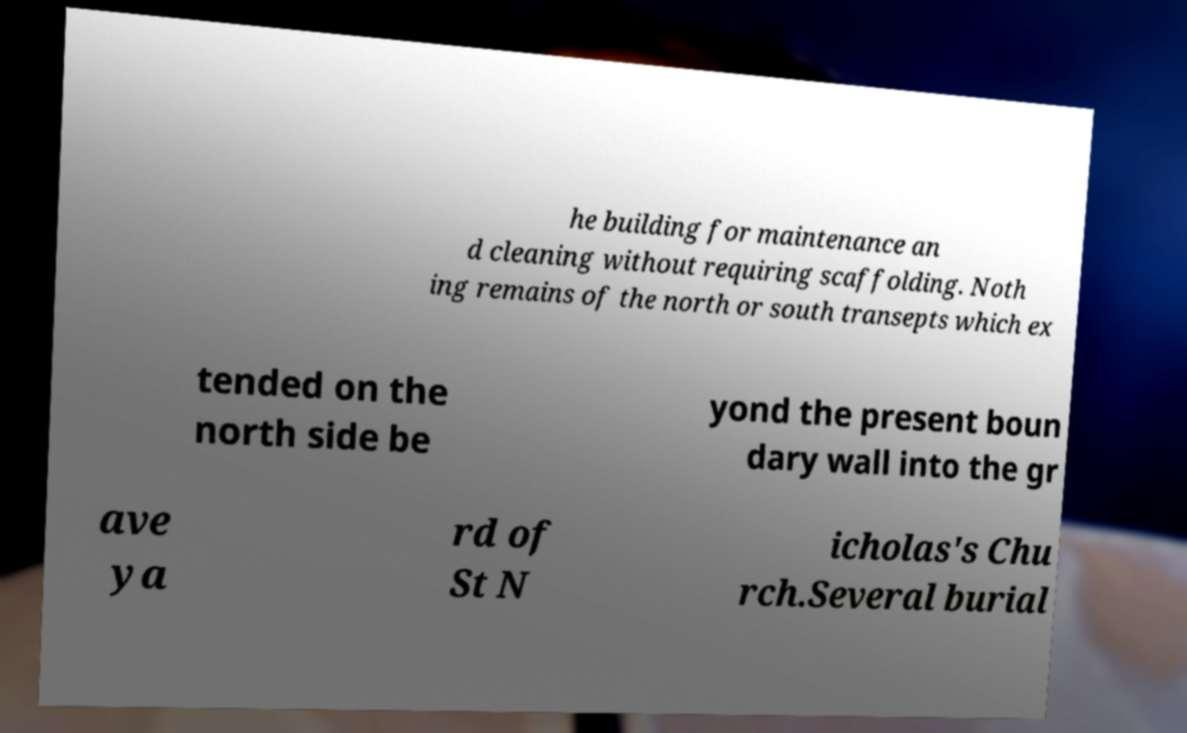Please read and relay the text visible in this image. What does it say? he building for maintenance an d cleaning without requiring scaffolding. Noth ing remains of the north or south transepts which ex tended on the north side be yond the present boun dary wall into the gr ave ya rd of St N icholas's Chu rch.Several burial 